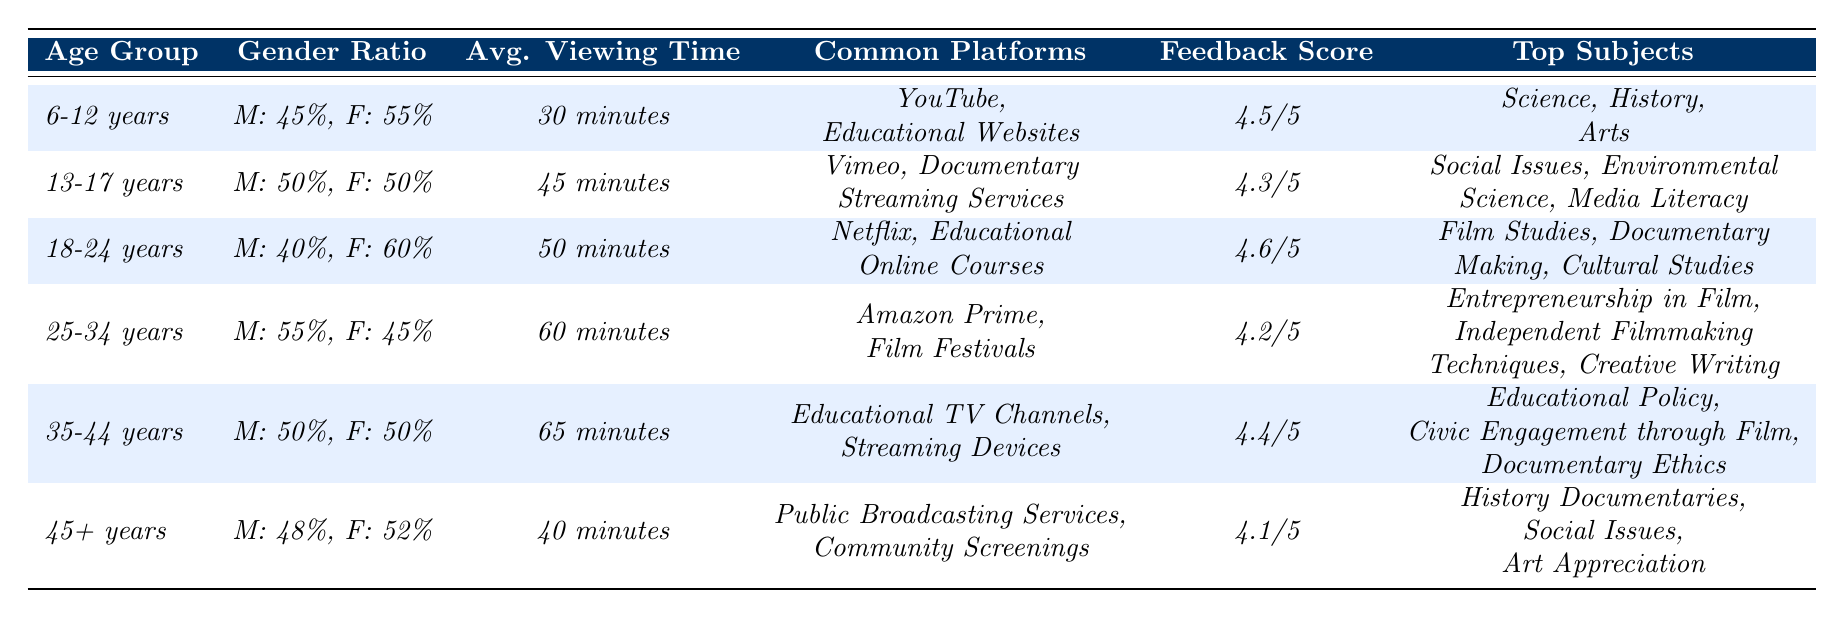What is the gender ratio of the 18-24 age group? The table shows that the gender ratio for the 18-24 age group is 40% male and 60% female.
Answer: 40% male and 60% female Which age group has the longest average viewing time? The average viewing times listed are 30, 45, 50, 60, 65, and 40 minutes. The longest is 65 minutes for the 35-44 age group.
Answer: 35-44 years What percentage of males view educational films in the 25-34 age group? The table states that the gender ratio for the 25-34 age group is 55% male.
Answer: 55% Are the common platforms for the 6-12 age group the same as those for the 45+ age group? The common platforms for the 6-12 age group are YouTube and Educational Websites, while for the 45+ age group, they are Public Broadcasting Services and Community Screenings. Since these are different, the answer is no.
Answer: No What is the average viewing time across all age groups? The viewing times are 30, 45, 50, 60, 65, and 40 minutes. Adding them gives 290 minutes, and dividing by 6 age groups gives an average of approximately 48.33 minutes.
Answer: Approximately 48.33 minutes Which age group has the highest feedback score, and what is that score? The feedback scores for the age groups are 4.5, 4.3, 4.6, 4.2, 4.4, and 4.1. The highest score is 4.6 for the 18-24 age group.
Answer: 18-24 years, 4.6/5 Is the feedback score for the 35-44 age group greater than that of the 45+ age group? The feedback score for the 35-44 age group is 4.4, and for the 45+ age group, it is 4.1. Since 4.4 is greater than 4.1, the answer is yes.
Answer: Yes What are the top subjects for viewers aged 13-17? According to the table, the top subjects for the 13-17 age group are Social Issues, Environmental Science, and Media Literacy.
Answer: Social Issues, Environmental Science, Media Literacy How do the average viewing times of the 25-34 and 35-44 age groups compare? The average viewing time for the 25-34 age group is 60 minutes, and for the 35-44 age group, it is 65 minutes. Since 65 is greater than 60, the 35-44 age group has a longer viewing time.
Answer: 35-44 age group has a longer viewing time If we consider the gender ratio, which gender has a higher percentage in the 6-12 age group? The gender ratio indicates males at 45% and females at 55%. Since 55% is greater than 45%, females have a higher percentage.
Answer: Females have a higher percentage 